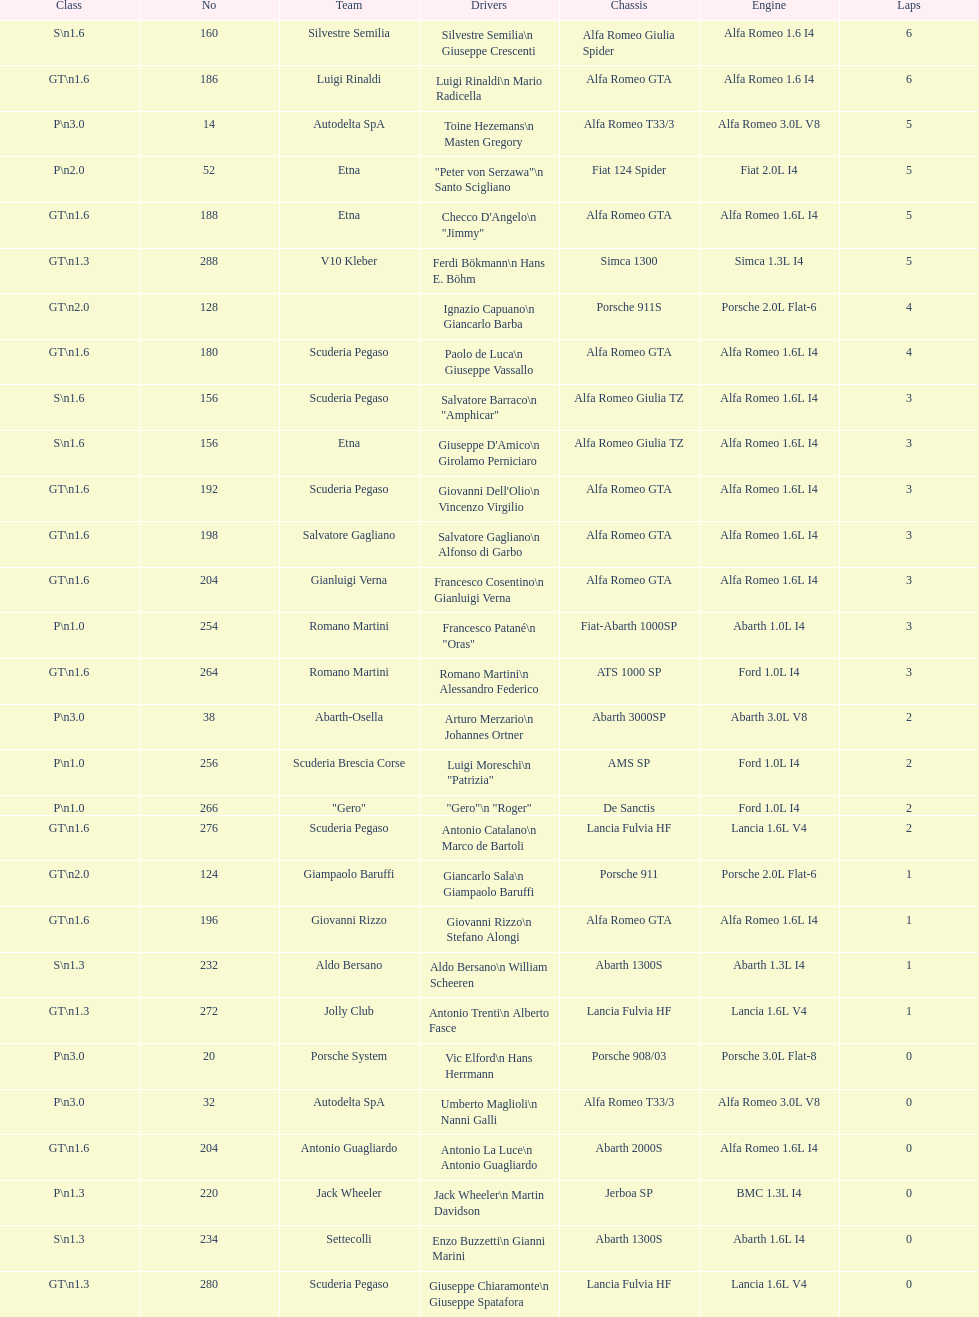How many teams were unable to finish the race following the completion of 2 laps? 4. 